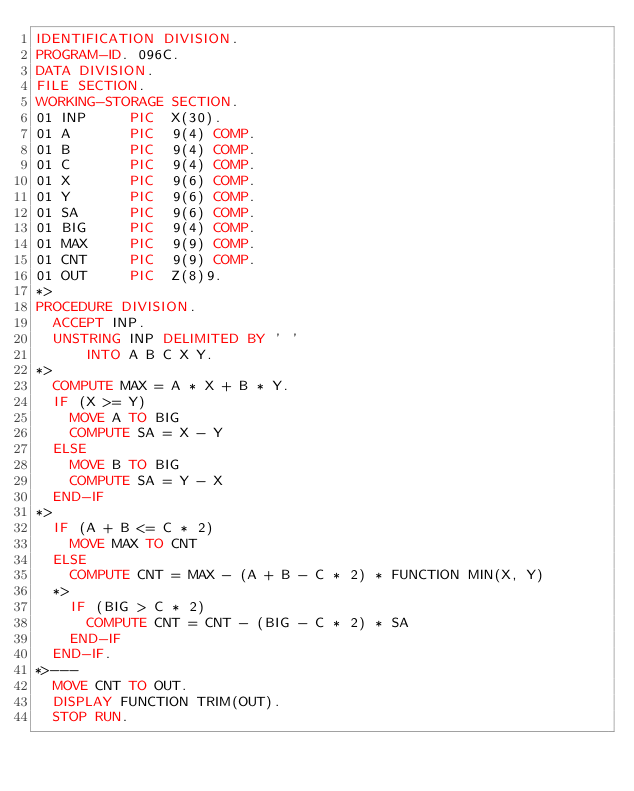<code> <loc_0><loc_0><loc_500><loc_500><_COBOL_>IDENTIFICATION DIVISION.
PROGRAM-ID. 096C.
DATA DIVISION.
FILE SECTION.
WORKING-STORAGE SECTION.
01 INP     PIC  X(30).
01 A       PIC  9(4) COMP.
01 B       PIC  9(4) COMP.
01 C       PIC  9(4) COMP.
01 X       PIC  9(6) COMP.
01 Y       PIC  9(6) COMP.
01 SA      PIC  9(6) COMP.
01 BIG     PIC  9(4) COMP.
01 MAX     PIC  9(9) COMP.
01 CNT     PIC  9(9) COMP.
01 OUT     PIC  Z(8)9.
*>
PROCEDURE DIVISION.
  ACCEPT INP.
  UNSTRING INP DELIMITED BY ' '
      INTO A B C X Y. 
*>
  COMPUTE MAX = A * X + B * Y.
  IF (X >= Y)
    MOVE A TO BIG
    COMPUTE SA = X - Y
  ELSE
    MOVE B TO BIG
    COMPUTE SA = Y - X
  END-IF
*>
  IF (A + B <= C * 2)
    MOVE MAX TO CNT
  ELSE
    COMPUTE CNT = MAX - (A + B - C * 2) * FUNCTION MIN(X, Y)
  *> 
    IF (BIG > C * 2)
      COMPUTE CNT = CNT - (BIG - C * 2) * SA
    END-IF 
  END-IF. 
*>---
  MOVE CNT TO OUT.
  DISPLAY FUNCTION TRIM(OUT).
  STOP RUN.
</code> 